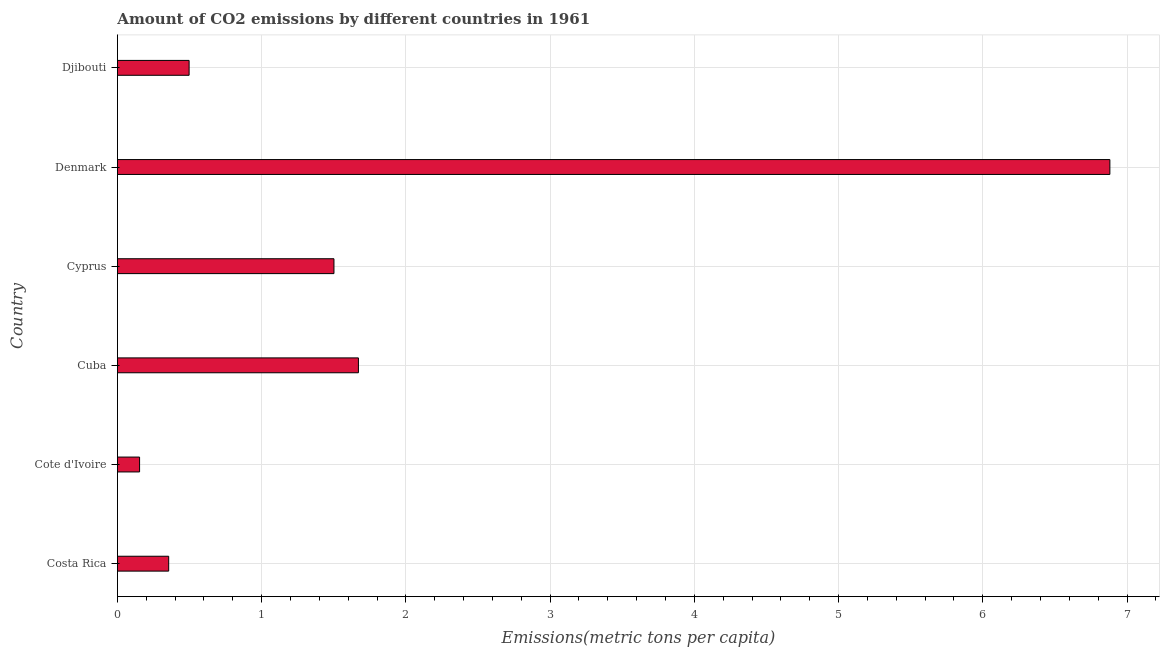Does the graph contain grids?
Your answer should be compact. Yes. What is the title of the graph?
Offer a terse response. Amount of CO2 emissions by different countries in 1961. What is the label or title of the X-axis?
Ensure brevity in your answer.  Emissions(metric tons per capita). What is the label or title of the Y-axis?
Provide a short and direct response. Country. What is the amount of co2 emissions in Djibouti?
Ensure brevity in your answer.  0.5. Across all countries, what is the maximum amount of co2 emissions?
Your answer should be compact. 6.88. Across all countries, what is the minimum amount of co2 emissions?
Offer a very short reply. 0.15. In which country was the amount of co2 emissions minimum?
Keep it short and to the point. Cote d'Ivoire. What is the sum of the amount of co2 emissions?
Provide a short and direct response. 11.06. What is the difference between the amount of co2 emissions in Costa Rica and Cuba?
Your answer should be very brief. -1.31. What is the average amount of co2 emissions per country?
Provide a succinct answer. 1.84. What is the median amount of co2 emissions?
Provide a succinct answer. 1. What is the ratio of the amount of co2 emissions in Costa Rica to that in Denmark?
Make the answer very short. 0.05. Is the difference between the amount of co2 emissions in Costa Rica and Cuba greater than the difference between any two countries?
Your answer should be very brief. No. What is the difference between the highest and the second highest amount of co2 emissions?
Offer a terse response. 5.21. What is the difference between the highest and the lowest amount of co2 emissions?
Ensure brevity in your answer.  6.73. In how many countries, is the amount of co2 emissions greater than the average amount of co2 emissions taken over all countries?
Make the answer very short. 1. How many bars are there?
Keep it short and to the point. 6. Are all the bars in the graph horizontal?
Provide a succinct answer. Yes. What is the difference between two consecutive major ticks on the X-axis?
Your response must be concise. 1. What is the Emissions(metric tons per capita) in Costa Rica?
Make the answer very short. 0.36. What is the Emissions(metric tons per capita) in Cote d'Ivoire?
Your answer should be compact. 0.15. What is the Emissions(metric tons per capita) in Cuba?
Provide a succinct answer. 1.67. What is the Emissions(metric tons per capita) in Cyprus?
Ensure brevity in your answer.  1.5. What is the Emissions(metric tons per capita) of Denmark?
Your answer should be compact. 6.88. What is the Emissions(metric tons per capita) of Djibouti?
Make the answer very short. 0.5. What is the difference between the Emissions(metric tons per capita) in Costa Rica and Cote d'Ivoire?
Offer a terse response. 0.2. What is the difference between the Emissions(metric tons per capita) in Costa Rica and Cuba?
Give a very brief answer. -1.32. What is the difference between the Emissions(metric tons per capita) in Costa Rica and Cyprus?
Ensure brevity in your answer.  -1.15. What is the difference between the Emissions(metric tons per capita) in Costa Rica and Denmark?
Make the answer very short. -6.53. What is the difference between the Emissions(metric tons per capita) in Costa Rica and Djibouti?
Offer a terse response. -0.14. What is the difference between the Emissions(metric tons per capita) in Cote d'Ivoire and Cuba?
Your answer should be very brief. -1.52. What is the difference between the Emissions(metric tons per capita) in Cote d'Ivoire and Cyprus?
Provide a succinct answer. -1.35. What is the difference between the Emissions(metric tons per capita) in Cote d'Ivoire and Denmark?
Make the answer very short. -6.73. What is the difference between the Emissions(metric tons per capita) in Cote d'Ivoire and Djibouti?
Your response must be concise. -0.34. What is the difference between the Emissions(metric tons per capita) in Cuba and Cyprus?
Your answer should be compact. 0.17. What is the difference between the Emissions(metric tons per capita) in Cuba and Denmark?
Give a very brief answer. -5.21. What is the difference between the Emissions(metric tons per capita) in Cuba and Djibouti?
Offer a terse response. 1.17. What is the difference between the Emissions(metric tons per capita) in Cyprus and Denmark?
Your answer should be very brief. -5.38. What is the difference between the Emissions(metric tons per capita) in Cyprus and Djibouti?
Provide a short and direct response. 1. What is the difference between the Emissions(metric tons per capita) in Denmark and Djibouti?
Your response must be concise. 6.38. What is the ratio of the Emissions(metric tons per capita) in Costa Rica to that in Cote d'Ivoire?
Offer a very short reply. 2.31. What is the ratio of the Emissions(metric tons per capita) in Costa Rica to that in Cuba?
Give a very brief answer. 0.21. What is the ratio of the Emissions(metric tons per capita) in Costa Rica to that in Cyprus?
Your answer should be very brief. 0.24. What is the ratio of the Emissions(metric tons per capita) in Costa Rica to that in Denmark?
Keep it short and to the point. 0.05. What is the ratio of the Emissions(metric tons per capita) in Costa Rica to that in Djibouti?
Your answer should be very brief. 0.71. What is the ratio of the Emissions(metric tons per capita) in Cote d'Ivoire to that in Cuba?
Offer a very short reply. 0.09. What is the ratio of the Emissions(metric tons per capita) in Cote d'Ivoire to that in Cyprus?
Provide a short and direct response. 0.1. What is the ratio of the Emissions(metric tons per capita) in Cote d'Ivoire to that in Denmark?
Make the answer very short. 0.02. What is the ratio of the Emissions(metric tons per capita) in Cote d'Ivoire to that in Djibouti?
Offer a terse response. 0.31. What is the ratio of the Emissions(metric tons per capita) in Cuba to that in Cyprus?
Provide a succinct answer. 1.11. What is the ratio of the Emissions(metric tons per capita) in Cuba to that in Denmark?
Your response must be concise. 0.24. What is the ratio of the Emissions(metric tons per capita) in Cuba to that in Djibouti?
Offer a very short reply. 3.36. What is the ratio of the Emissions(metric tons per capita) in Cyprus to that in Denmark?
Give a very brief answer. 0.22. What is the ratio of the Emissions(metric tons per capita) in Cyprus to that in Djibouti?
Ensure brevity in your answer.  3.02. What is the ratio of the Emissions(metric tons per capita) in Denmark to that in Djibouti?
Offer a terse response. 13.84. 